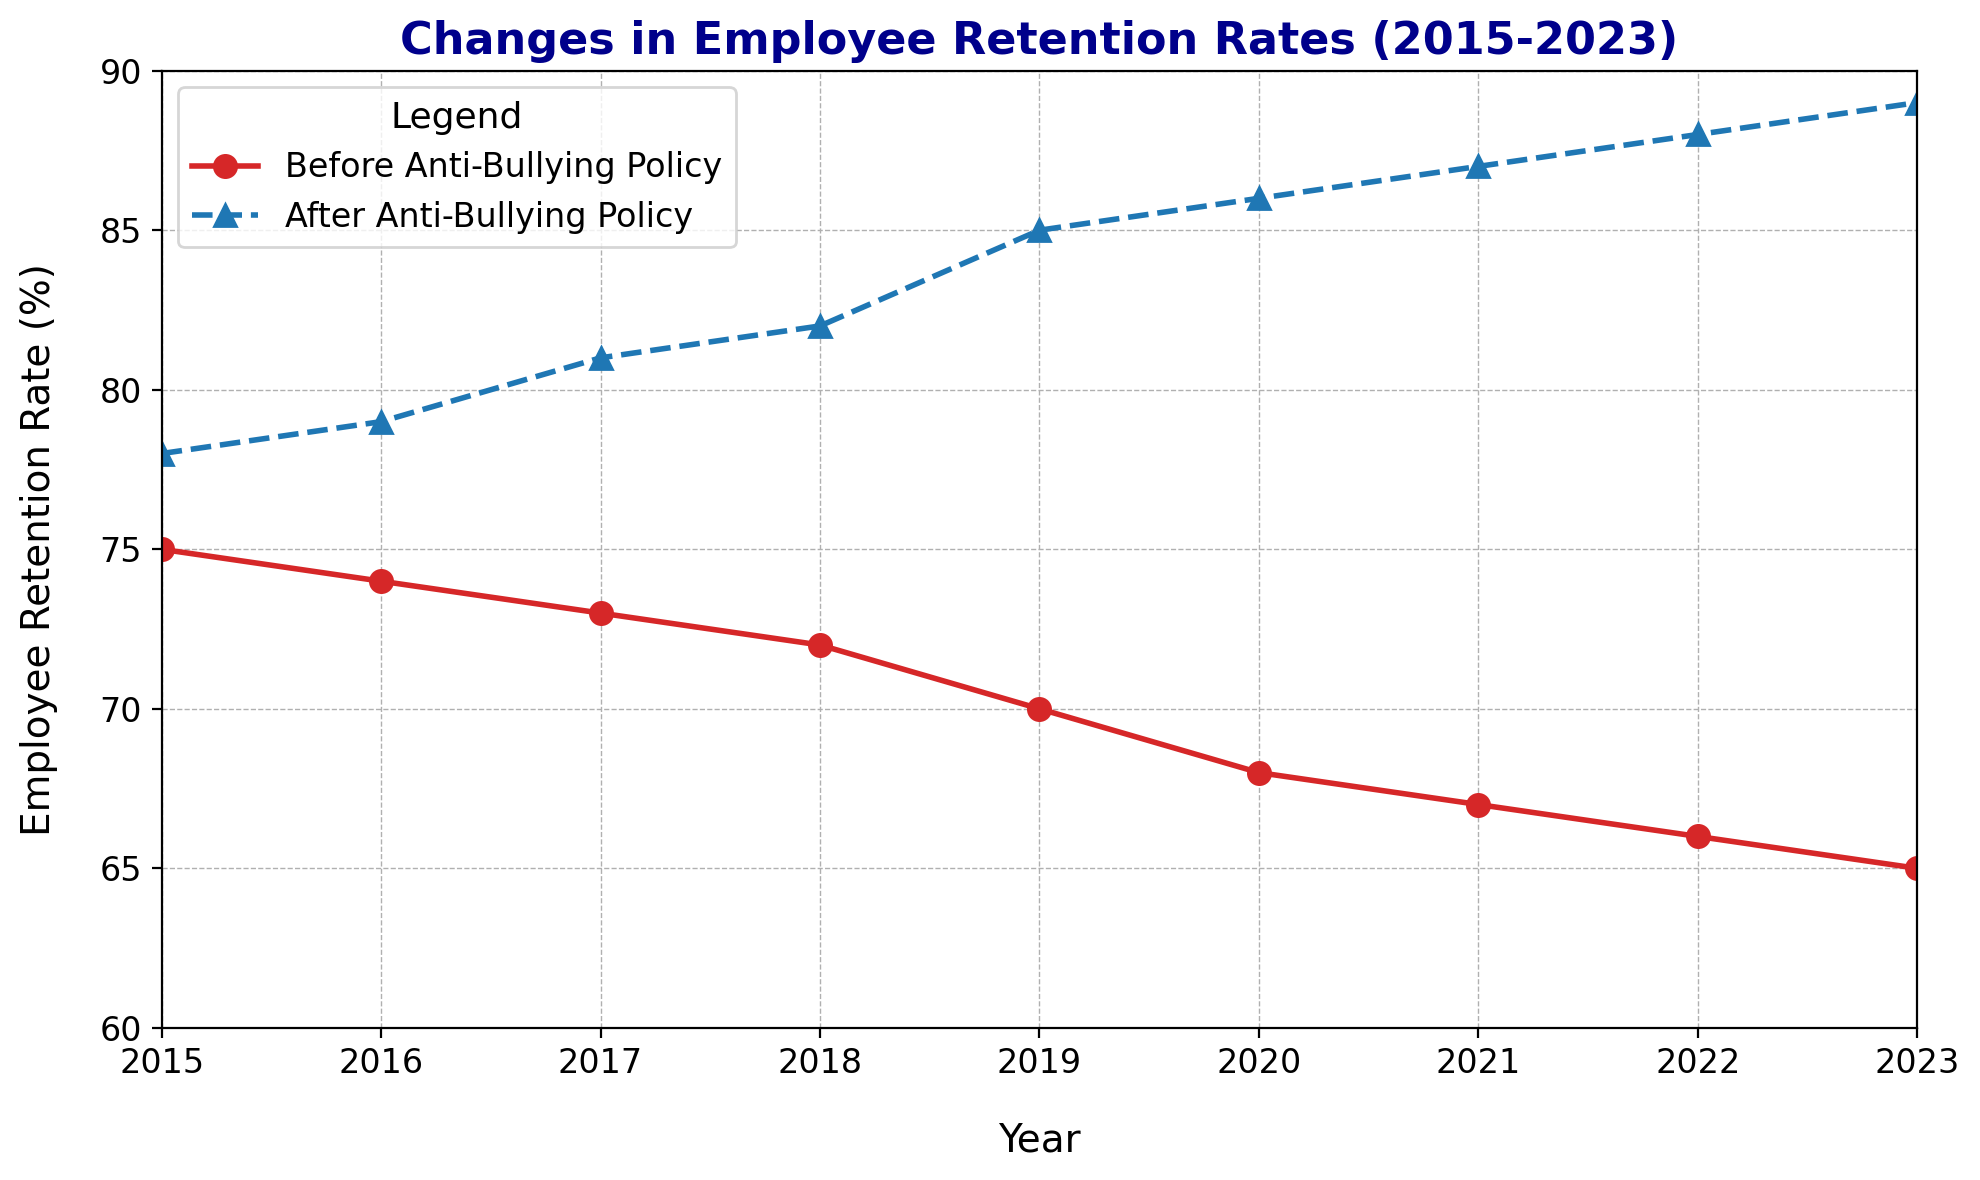What is the difference in employee retention rates between 2015 and 2023 before implementing the anti-bullying policy? To find the difference, subtract the retention rate in 2023 from that in 2015 (75% - 65%). The difference is 10%.
Answer: 10% How does the retention rate in 2020 after implementing the anti-bullying policy compare to the same year before implementation? Look at the retention rates in 2020 before and after the anti-bullying policy. The retention rate before was 68% and after was 86%. The retention rate after is higher.
Answer: Retention rate after is higher by 18% Which year shows the largest gap between retention rates before and after implementing the policy? Find the difference between the retention rates before and after for each year. The largest gap is found in 2023 (89% - 65%).
Answer: 2023 What is the average retention rate before the anti-bullying policy from 2015 to 2023? Add the retention rates from 2015 to 2023 for "Before Anti-Bullying Policy" and divide by the number of years: (75 + 74 + 73 + 72 + 70 + 68 + 67 + 66 + 65) / 9. The average is approximately 70.
Answer: 70% Does the retention rate increase or decrease over the years after the anti-bullying policy was introduced? Observe the trend in the retention rates after the policy from 2015 to 2023. The retention rate monotonically increases from 78% to 89%.
Answer: Increases Between which consecutive years is the retention rate change highest for the "After Anti-Bullying Policy" data? Calculate the retention rate change between consecutive years after the policy introduction and find the maximum change. From 2018 to 2019, it increases from 82% to 85%, showing the highest change of 3%.
Answer: 2018 to 2019 What is the total increase in retention rates from 2015 to 2023 for "After Anti-Bullying Policy"? Subtract the retention rate in 2015 from 2023 for "After Anti-Bullying Policy" (89% - 78%). The total increase is 11%.
Answer: 11% Which year's retention rate after implementing the policy is the closest to 85%? Compare the retention rates after implementing the policy to 85%. The 2019 retention rate is 85%.
Answer: 2019 What's the average difference in retention rates before and after the anti-bullying policy over the years? Calculate the differences for each year, add them up, and divide by the number of years: ((78-75) + (79-74) + (81-73) + (82-72) + (85-70) + (86-68) + (87-67) + (88-66) + (89-65))/9. The average difference is approximately 15.
Answer: 15% Which line represents employee retention rates after the anti-bullying policy? Examine the visual attributes like color and markers. The blue line with triangle markers represents the retention rates after the anti-bullying policy.
Answer: Blue line with triangle markers 